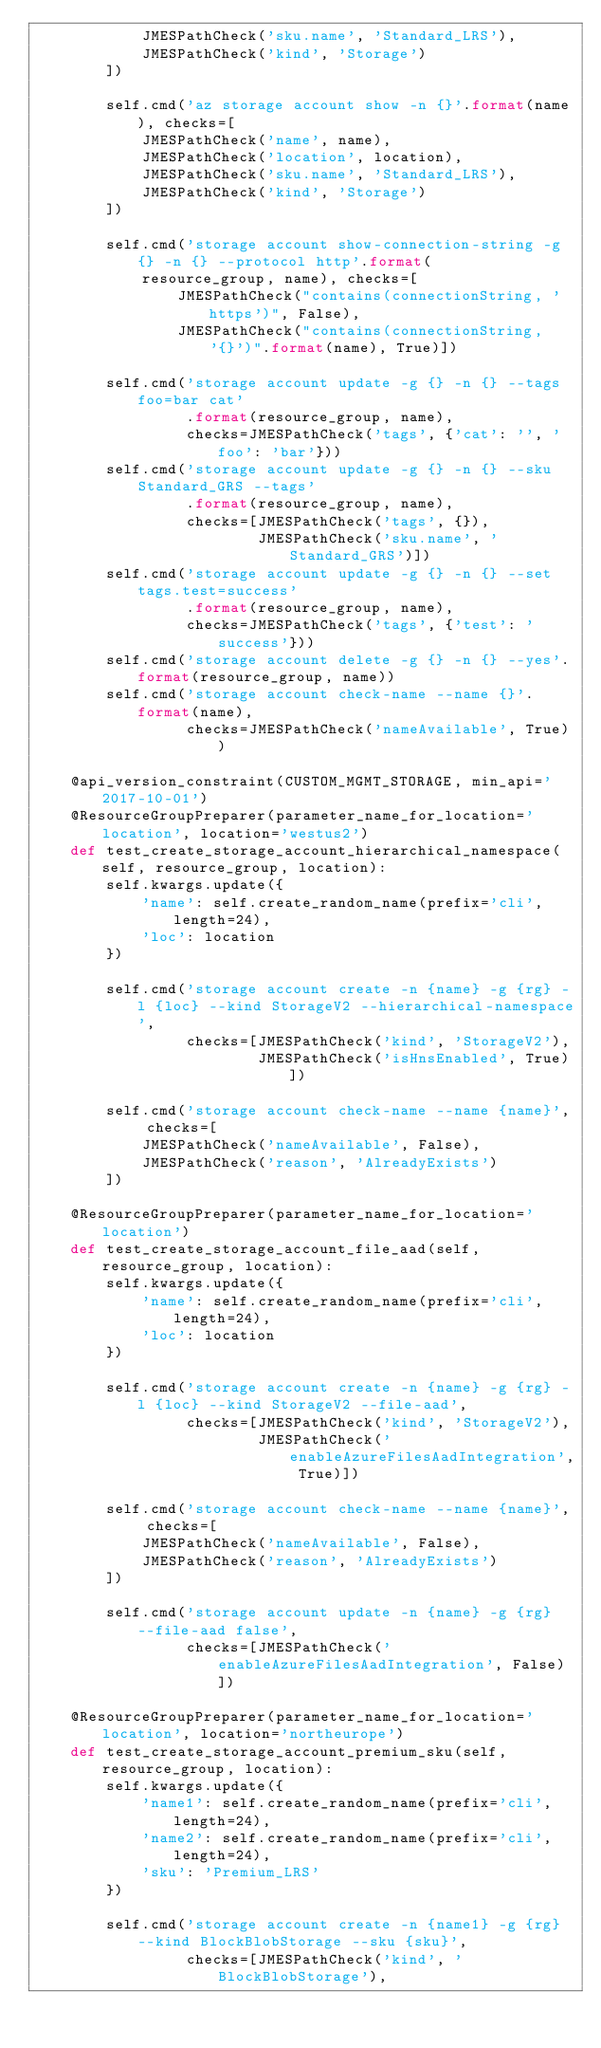<code> <loc_0><loc_0><loc_500><loc_500><_Python_>            JMESPathCheck('sku.name', 'Standard_LRS'),
            JMESPathCheck('kind', 'Storage')
        ])

        self.cmd('az storage account show -n {}'.format(name), checks=[
            JMESPathCheck('name', name),
            JMESPathCheck('location', location),
            JMESPathCheck('sku.name', 'Standard_LRS'),
            JMESPathCheck('kind', 'Storage')
        ])

        self.cmd('storage account show-connection-string -g {} -n {} --protocol http'.format(
            resource_group, name), checks=[
                JMESPathCheck("contains(connectionString, 'https')", False),
                JMESPathCheck("contains(connectionString, '{}')".format(name), True)])

        self.cmd('storage account update -g {} -n {} --tags foo=bar cat'
                 .format(resource_group, name),
                 checks=JMESPathCheck('tags', {'cat': '', 'foo': 'bar'}))
        self.cmd('storage account update -g {} -n {} --sku Standard_GRS --tags'
                 .format(resource_group, name),
                 checks=[JMESPathCheck('tags', {}),
                         JMESPathCheck('sku.name', 'Standard_GRS')])
        self.cmd('storage account update -g {} -n {} --set tags.test=success'
                 .format(resource_group, name),
                 checks=JMESPathCheck('tags', {'test': 'success'}))
        self.cmd('storage account delete -g {} -n {} --yes'.format(resource_group, name))
        self.cmd('storage account check-name --name {}'.format(name),
                 checks=JMESPathCheck('nameAvailable', True))

    @api_version_constraint(CUSTOM_MGMT_STORAGE, min_api='2017-10-01')
    @ResourceGroupPreparer(parameter_name_for_location='location', location='westus2')
    def test_create_storage_account_hierarchical_namespace(self, resource_group, location):
        self.kwargs.update({
            'name': self.create_random_name(prefix='cli', length=24),
            'loc': location
        })

        self.cmd('storage account create -n {name} -g {rg} -l {loc} --kind StorageV2 --hierarchical-namespace',
                 checks=[JMESPathCheck('kind', 'StorageV2'),
                         JMESPathCheck('isHnsEnabled', True)])

        self.cmd('storage account check-name --name {name}', checks=[
            JMESPathCheck('nameAvailable', False),
            JMESPathCheck('reason', 'AlreadyExists')
        ])

    @ResourceGroupPreparer(parameter_name_for_location='location')
    def test_create_storage_account_file_aad(self, resource_group, location):
        self.kwargs.update({
            'name': self.create_random_name(prefix='cli', length=24),
            'loc': location
        })

        self.cmd('storage account create -n {name} -g {rg} -l {loc} --kind StorageV2 --file-aad',
                 checks=[JMESPathCheck('kind', 'StorageV2'),
                         JMESPathCheck('enableAzureFilesAadIntegration', True)])

        self.cmd('storage account check-name --name {name}', checks=[
            JMESPathCheck('nameAvailable', False),
            JMESPathCheck('reason', 'AlreadyExists')
        ])

        self.cmd('storage account update -n {name} -g {rg} --file-aad false',
                 checks=[JMESPathCheck('enableAzureFilesAadIntegration', False)])

    @ResourceGroupPreparer(parameter_name_for_location='location', location='northeurope')
    def test_create_storage_account_premium_sku(self, resource_group, location):
        self.kwargs.update({
            'name1': self.create_random_name(prefix='cli', length=24),
            'name2': self.create_random_name(prefix='cli', length=24),
            'sku': 'Premium_LRS'
        })

        self.cmd('storage account create -n {name1} -g {rg} --kind BlockBlobStorage --sku {sku}',
                 checks=[JMESPathCheck('kind', 'BlockBlobStorage'),</code> 